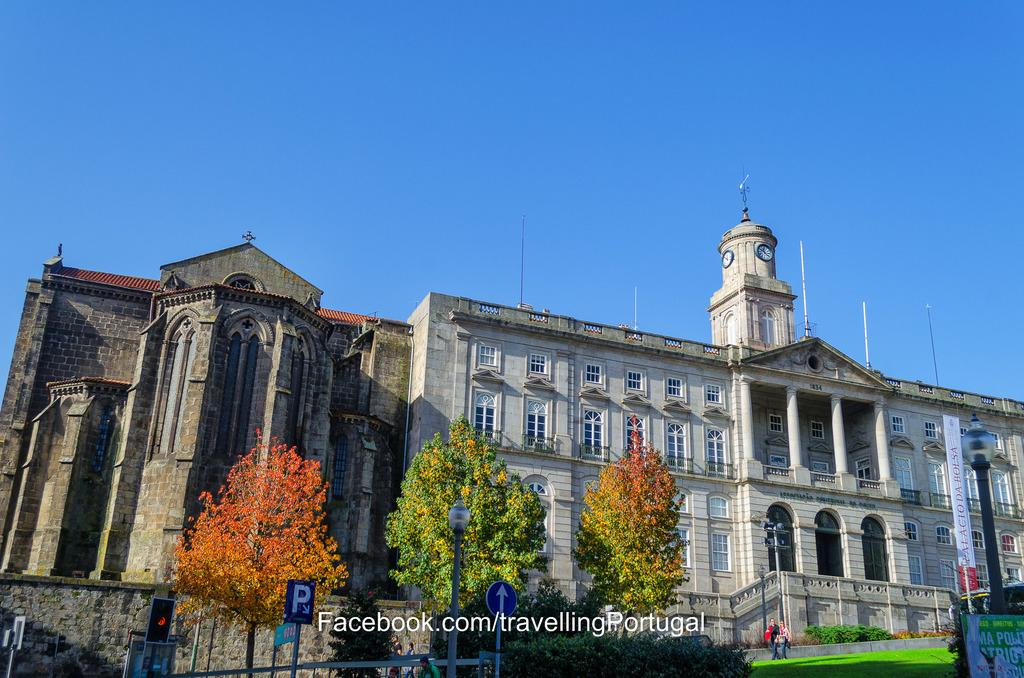<image>
Offer a succinct explanation of the picture presented. Unidentified stock photo with Facebook.com stamp of asite in Portugal with a brown stone church and large monumental building. 